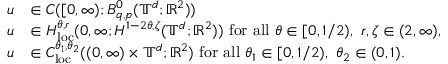<formula> <loc_0><loc_0><loc_500><loc_500>\begin{array} { r l } { u } & { \in C ( [ 0 , \infty ) ; B _ { q , p } ^ { 0 } ( \mathbb { T } ^ { d } ; { \mathbb { R } } ^ { 2 } ) ) } \\ { u } & { \in H _ { l o c } ^ { \theta , r } ( 0 , \infty ; H ^ { 1 - 2 \theta , \zeta } ( \mathbb { T } ^ { d } ; { \mathbb { R } } ^ { 2 } ) ) \ f o r a l l \theta \in [ 0 , 1 / 2 ) , \ r , \zeta \in ( 2 , \infty ) , } \\ { u } & { \in C _ { l o c } ^ { \theta _ { 1 } , \theta _ { 2 } } ( ( 0 , \infty ) \times \mathbb { T } ^ { d } ; { \mathbb { R } } ^ { 2 } ) \ f o r a l l \theta _ { 1 } \in [ 0 , 1 / 2 ) , \ \theta _ { 2 } \in ( 0 , 1 ) . } \end{array}</formula> 